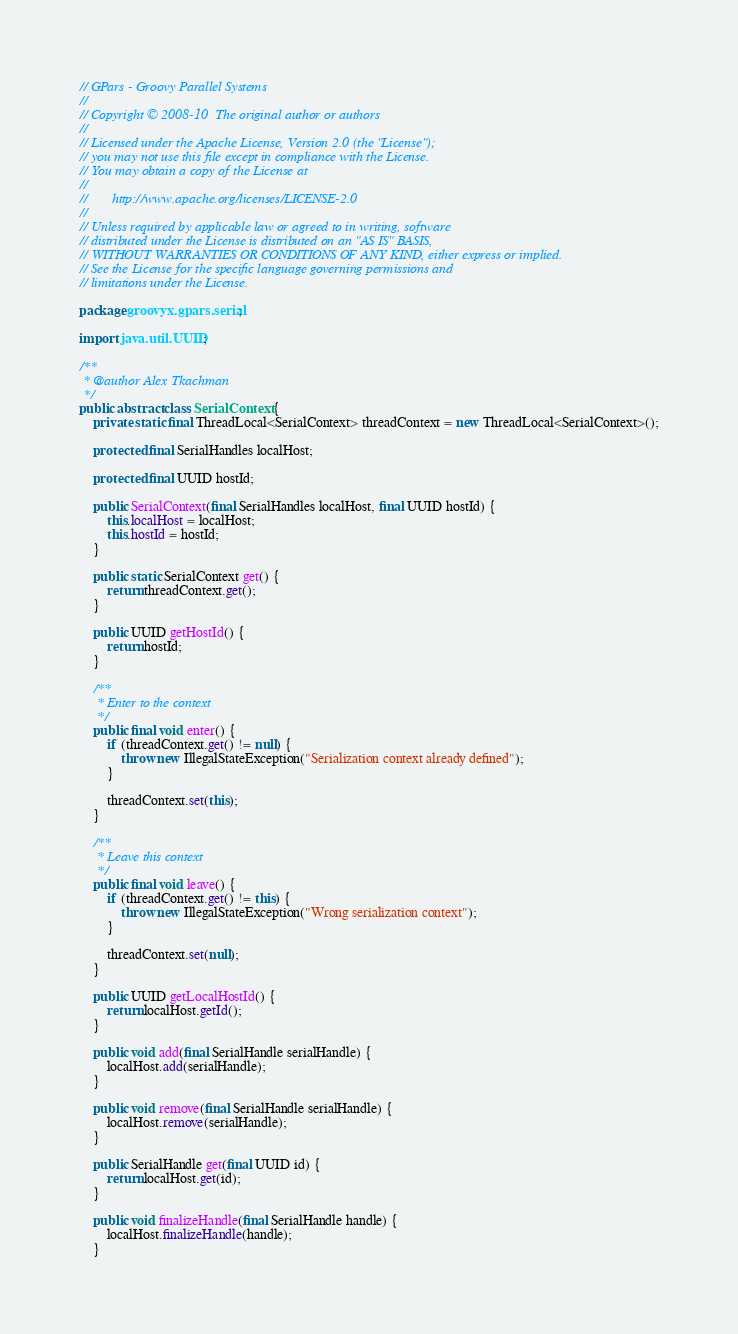Convert code to text. <code><loc_0><loc_0><loc_500><loc_500><_Java_>// GPars - Groovy Parallel Systems
//
// Copyright © 2008-10  The original author or authors
//
// Licensed under the Apache License, Version 2.0 (the "License");
// you may not use this file except in compliance with the License.
// You may obtain a copy of the License at
//
//       http://www.apache.org/licenses/LICENSE-2.0
//
// Unless required by applicable law or agreed to in writing, software
// distributed under the License is distributed on an "AS IS" BASIS,
// WITHOUT WARRANTIES OR CONDITIONS OF ANY KIND, either express or implied.
// See the License for the specific language governing permissions and
// limitations under the License.

package groovyx.gpars.serial;

import java.util.UUID;

/**
 * @author Alex Tkachman
 */
public abstract class SerialContext {
    private static final ThreadLocal<SerialContext> threadContext = new ThreadLocal<SerialContext>();

    protected final SerialHandles localHost;

    protected final UUID hostId;

    public SerialContext(final SerialHandles localHost, final UUID hostId) {
        this.localHost = localHost;
        this.hostId = hostId;
    }

    public static SerialContext get() {
        return threadContext.get();
    }

    public UUID getHostId() {
        return hostId;
    }

    /**
     * Enter to the context
     */
    public final void enter() {
        if (threadContext.get() != null) {
            throw new IllegalStateException("Serialization context already defined");
        }

        threadContext.set(this);
    }

    /**
     * Leave this context
     */
    public final void leave() {
        if (threadContext.get() != this) {
            throw new IllegalStateException("Wrong serialization context");
        }

        threadContext.set(null);
    }

    public UUID getLocalHostId() {
        return localHost.getId();
    }

    public void add(final SerialHandle serialHandle) {
        localHost.add(serialHandle);
    }

    public void remove(final SerialHandle serialHandle) {
        localHost.remove(serialHandle);
    }

    public SerialHandle get(final UUID id) {
        return localHost.get(id);
    }

    public void finalizeHandle(final SerialHandle handle) {
        localHost.finalizeHandle(handle);
    }
</code> 